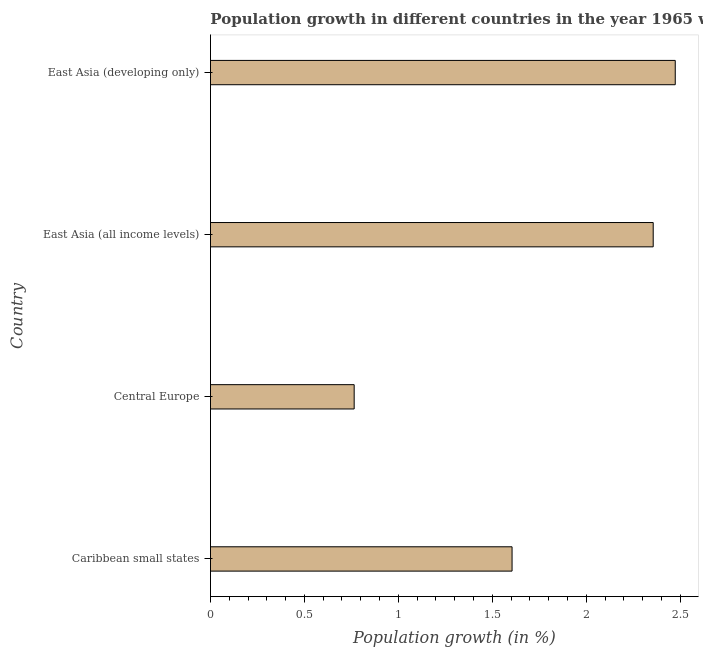Does the graph contain any zero values?
Your answer should be very brief. No. Does the graph contain grids?
Make the answer very short. No. What is the title of the graph?
Your answer should be very brief. Population growth in different countries in the year 1965 w.r.t it's previous year. What is the label or title of the X-axis?
Give a very brief answer. Population growth (in %). What is the population growth in East Asia (developing only)?
Ensure brevity in your answer.  2.47. Across all countries, what is the maximum population growth?
Your response must be concise. 2.47. Across all countries, what is the minimum population growth?
Give a very brief answer. 0.76. In which country was the population growth maximum?
Give a very brief answer. East Asia (developing only). In which country was the population growth minimum?
Keep it short and to the point. Central Europe. What is the sum of the population growth?
Give a very brief answer. 7.2. What is the difference between the population growth in Caribbean small states and East Asia (developing only)?
Your response must be concise. -0.87. What is the median population growth?
Ensure brevity in your answer.  1.98. What is the ratio of the population growth in Caribbean small states to that in Central Europe?
Give a very brief answer. 2.1. Is the difference between the population growth in Caribbean small states and East Asia (all income levels) greater than the difference between any two countries?
Your answer should be very brief. No. What is the difference between the highest and the second highest population growth?
Ensure brevity in your answer.  0.12. What is the difference between the highest and the lowest population growth?
Give a very brief answer. 1.71. How many bars are there?
Make the answer very short. 4. How many countries are there in the graph?
Give a very brief answer. 4. What is the difference between two consecutive major ticks on the X-axis?
Ensure brevity in your answer.  0.5. What is the Population growth (in %) of Caribbean small states?
Your answer should be compact. 1.61. What is the Population growth (in %) in Central Europe?
Make the answer very short. 0.76. What is the Population growth (in %) in East Asia (all income levels)?
Provide a short and direct response. 2.36. What is the Population growth (in %) in East Asia (developing only)?
Give a very brief answer. 2.47. What is the difference between the Population growth (in %) in Caribbean small states and Central Europe?
Offer a terse response. 0.84. What is the difference between the Population growth (in %) in Caribbean small states and East Asia (all income levels)?
Offer a very short reply. -0.75. What is the difference between the Population growth (in %) in Caribbean small states and East Asia (developing only)?
Your answer should be very brief. -0.87. What is the difference between the Population growth (in %) in Central Europe and East Asia (all income levels)?
Offer a very short reply. -1.59. What is the difference between the Population growth (in %) in Central Europe and East Asia (developing only)?
Provide a short and direct response. -1.71. What is the difference between the Population growth (in %) in East Asia (all income levels) and East Asia (developing only)?
Make the answer very short. -0.12. What is the ratio of the Population growth (in %) in Caribbean small states to that in Central Europe?
Provide a succinct answer. 2.1. What is the ratio of the Population growth (in %) in Caribbean small states to that in East Asia (all income levels)?
Make the answer very short. 0.68. What is the ratio of the Population growth (in %) in Caribbean small states to that in East Asia (developing only)?
Ensure brevity in your answer.  0.65. What is the ratio of the Population growth (in %) in Central Europe to that in East Asia (all income levels)?
Your answer should be compact. 0.33. What is the ratio of the Population growth (in %) in Central Europe to that in East Asia (developing only)?
Your answer should be very brief. 0.31. What is the ratio of the Population growth (in %) in East Asia (all income levels) to that in East Asia (developing only)?
Keep it short and to the point. 0.95. 